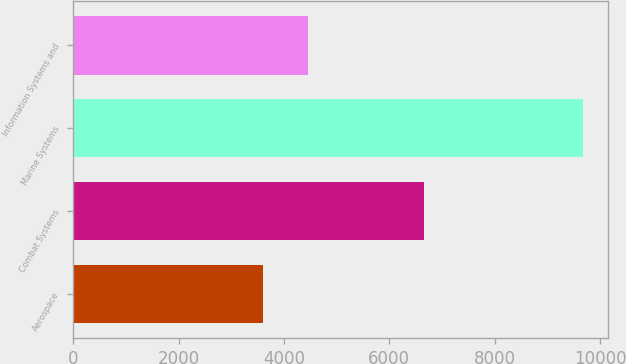Convert chart. <chart><loc_0><loc_0><loc_500><loc_500><bar_chart><fcel>Aerospace<fcel>Combat Systems<fcel>Marine Systems<fcel>Information Systems and<nl><fcel>3610<fcel>6649<fcel>9670<fcel>4462<nl></chart> 